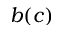<formula> <loc_0><loc_0><loc_500><loc_500>b ( c )</formula> 